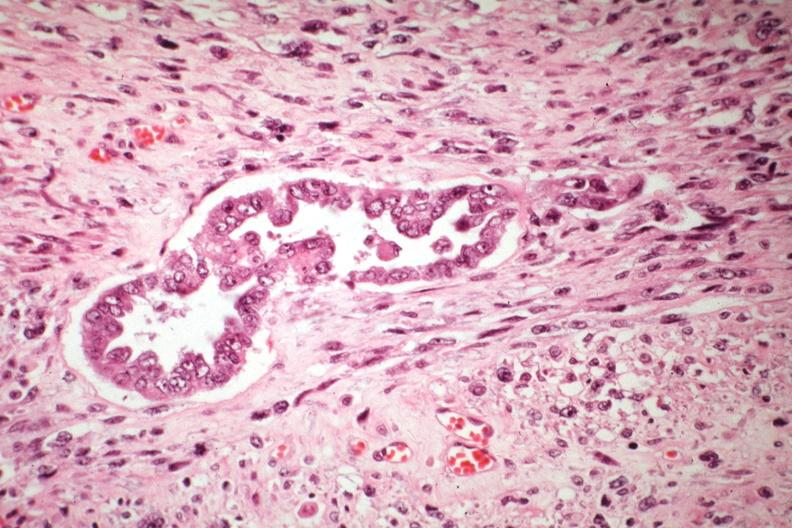s female reproductive present?
Answer the question using a single word or phrase. Yes 